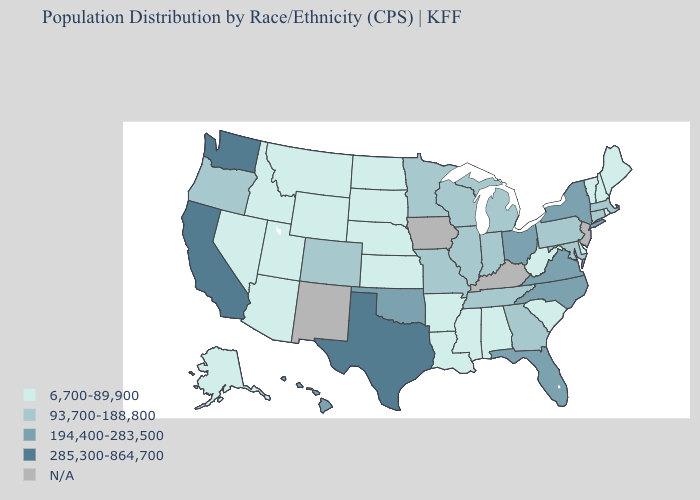Does Indiana have the lowest value in the USA?
Write a very short answer. No. Name the states that have a value in the range 285,300-864,700?
Be succinct. California, Texas, Washington. Name the states that have a value in the range N/A?
Short answer required. Iowa, Kentucky, New Jersey, New Mexico. Name the states that have a value in the range 6,700-89,900?
Short answer required. Alabama, Alaska, Arizona, Arkansas, Delaware, Idaho, Kansas, Louisiana, Maine, Mississippi, Montana, Nebraska, Nevada, New Hampshire, North Dakota, Rhode Island, South Carolina, South Dakota, Utah, Vermont, West Virginia, Wyoming. What is the lowest value in the USA?
Write a very short answer. 6,700-89,900. What is the value of Alaska?
Be succinct. 6,700-89,900. What is the value of Ohio?
Be succinct. 194,400-283,500. What is the highest value in the USA?
Answer briefly. 285,300-864,700. What is the lowest value in the West?
Answer briefly. 6,700-89,900. What is the highest value in states that border Delaware?
Answer briefly. 93,700-188,800. What is the value of Kentucky?
Quick response, please. N/A. What is the value of South Carolina?
Quick response, please. 6,700-89,900. Does Washington have the highest value in the West?
Short answer required. Yes. Among the states that border Missouri , which have the highest value?
Quick response, please. Oklahoma. 